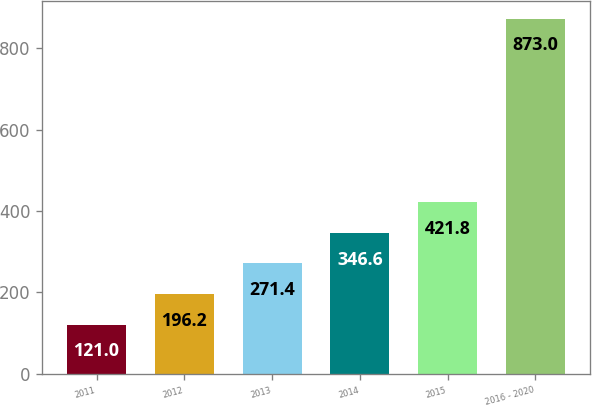Convert chart. <chart><loc_0><loc_0><loc_500><loc_500><bar_chart><fcel>2011<fcel>2012<fcel>2013<fcel>2014<fcel>2015<fcel>2016 - 2020<nl><fcel>121<fcel>196.2<fcel>271.4<fcel>346.6<fcel>421.8<fcel>873<nl></chart> 